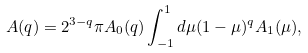<formula> <loc_0><loc_0><loc_500><loc_500>A ( q ) = 2 ^ { 3 - q } \pi A _ { 0 } ( q ) \int _ { - 1 } ^ { 1 } d \mu ( 1 - \mu ) ^ { q } A _ { 1 } ( \mu ) ,</formula> 